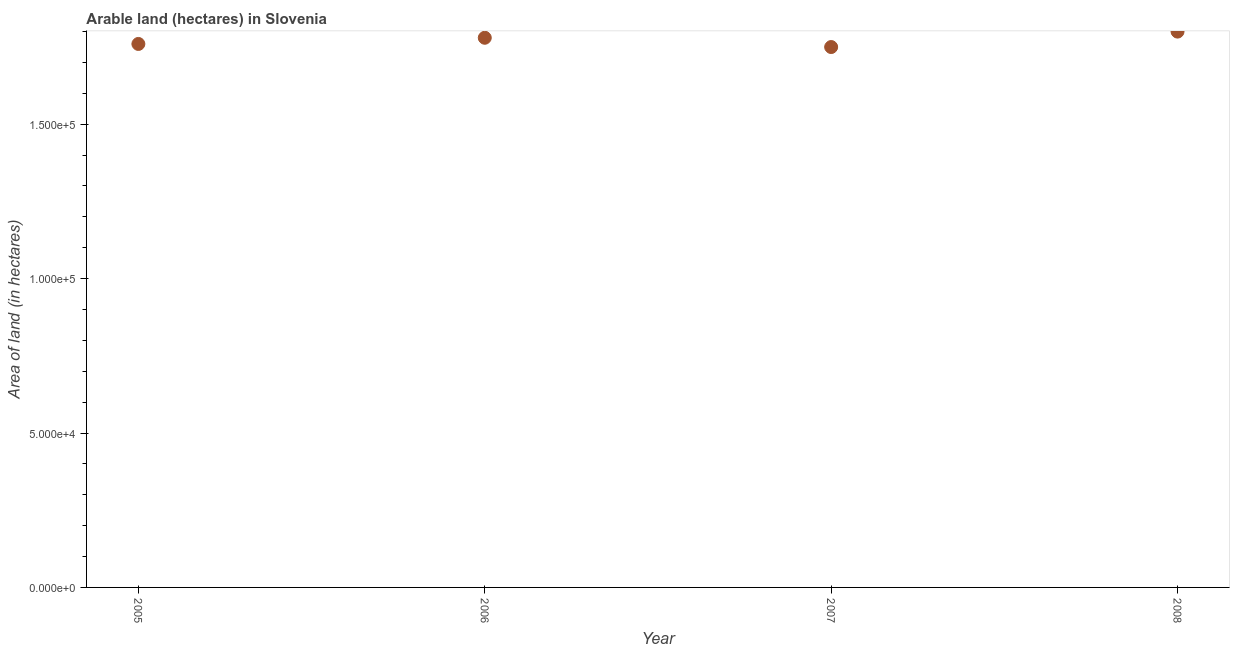What is the area of land in 2007?
Your response must be concise. 1.75e+05. Across all years, what is the maximum area of land?
Provide a short and direct response. 1.80e+05. Across all years, what is the minimum area of land?
Your answer should be compact. 1.75e+05. What is the sum of the area of land?
Ensure brevity in your answer.  7.09e+05. What is the difference between the area of land in 2006 and 2008?
Your answer should be very brief. -2000. What is the average area of land per year?
Your response must be concise. 1.77e+05. What is the median area of land?
Ensure brevity in your answer.  1.77e+05. Do a majority of the years between 2005 and 2008 (inclusive) have area of land greater than 10000 hectares?
Give a very brief answer. Yes. What is the ratio of the area of land in 2006 to that in 2007?
Provide a succinct answer. 1.02. Is the area of land in 2007 less than that in 2008?
Keep it short and to the point. Yes. Is the difference between the area of land in 2005 and 2006 greater than the difference between any two years?
Provide a short and direct response. No. What is the difference between the highest and the lowest area of land?
Offer a very short reply. 5000. In how many years, is the area of land greater than the average area of land taken over all years?
Provide a short and direct response. 2. How many dotlines are there?
Offer a very short reply. 1. Does the graph contain any zero values?
Give a very brief answer. No. Does the graph contain grids?
Provide a succinct answer. No. What is the title of the graph?
Your answer should be very brief. Arable land (hectares) in Slovenia. What is the label or title of the Y-axis?
Make the answer very short. Area of land (in hectares). What is the Area of land (in hectares) in 2005?
Give a very brief answer. 1.76e+05. What is the Area of land (in hectares) in 2006?
Your answer should be compact. 1.78e+05. What is the Area of land (in hectares) in 2007?
Offer a very short reply. 1.75e+05. What is the difference between the Area of land (in hectares) in 2005 and 2006?
Provide a succinct answer. -2000. What is the difference between the Area of land (in hectares) in 2005 and 2008?
Your answer should be compact. -4000. What is the difference between the Area of land (in hectares) in 2006 and 2007?
Provide a short and direct response. 3000. What is the difference between the Area of land (in hectares) in 2006 and 2008?
Keep it short and to the point. -2000. What is the difference between the Area of land (in hectares) in 2007 and 2008?
Make the answer very short. -5000. What is the ratio of the Area of land (in hectares) in 2005 to that in 2006?
Provide a succinct answer. 0.99. What is the ratio of the Area of land (in hectares) in 2006 to that in 2007?
Your response must be concise. 1.02. What is the ratio of the Area of land (in hectares) in 2007 to that in 2008?
Offer a terse response. 0.97. 